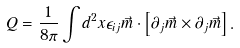<formula> <loc_0><loc_0><loc_500><loc_500>Q = \frac { 1 } { 8 \pi } \int d ^ { 2 } x \epsilon _ { i j } \vec { m } \cdot \left [ \partial _ { j } \vec { m } \times \partial _ { j } \vec { m } \right ] .</formula> 